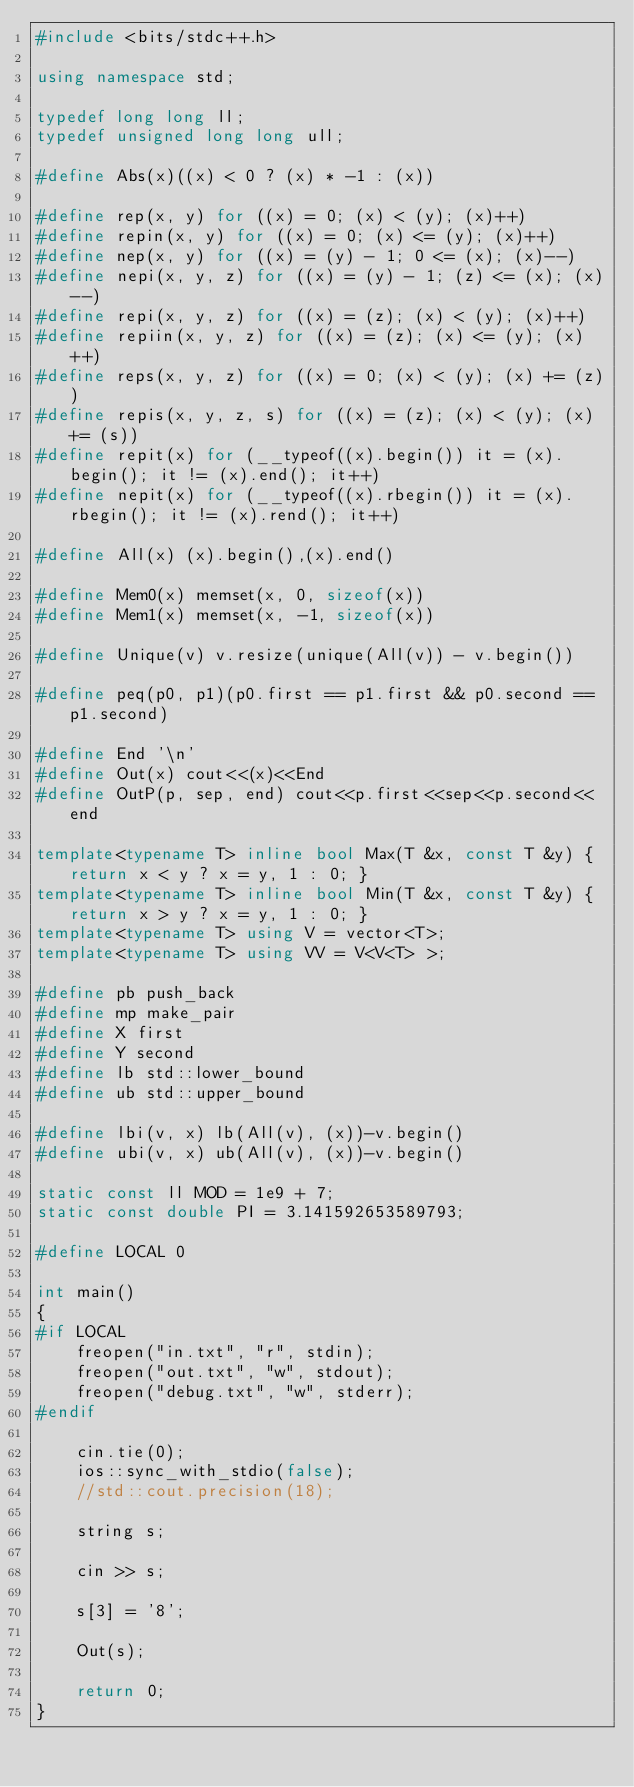Convert code to text. <code><loc_0><loc_0><loc_500><loc_500><_C++_>#include <bits/stdc++.h>

using namespace std;

typedef long long ll;
typedef unsigned long long ull;

#define Abs(x)((x) < 0 ? (x) * -1 : (x))

#define rep(x, y) for ((x) = 0; (x) < (y); (x)++)
#define repin(x, y) for ((x) = 0; (x) <= (y); (x)++)
#define nep(x, y) for ((x) = (y) - 1; 0 <= (x); (x)--)
#define nepi(x, y, z) for ((x) = (y) - 1; (z) <= (x); (x)--)
#define repi(x, y, z) for ((x) = (z); (x) < (y); (x)++)
#define repiin(x, y, z) for ((x) = (z); (x) <= (y); (x)++)
#define reps(x, y, z) for ((x) = 0; (x) < (y); (x) += (z))
#define repis(x, y, z, s) for ((x) = (z); (x) < (y); (x) += (s))
#define repit(x) for (__typeof((x).begin()) it = (x).begin(); it != (x).end(); it++)
#define nepit(x) for (__typeof((x).rbegin()) it = (x).rbegin(); it != (x).rend(); it++)

#define All(x) (x).begin(),(x).end()

#define Mem0(x) memset(x, 0, sizeof(x))
#define Mem1(x) memset(x, -1, sizeof(x))

#define Unique(v) v.resize(unique(All(v)) - v.begin())

#define peq(p0, p1)(p0.first == p1.first && p0.second == p1.second)

#define End '\n'
#define Out(x) cout<<(x)<<End
#define OutP(p, sep, end) cout<<p.first<<sep<<p.second<<end

template<typename T> inline bool Max(T &x, const T &y) { return x < y ? x = y, 1 : 0; }
template<typename T> inline bool Min(T &x, const T &y) { return x > y ? x = y, 1 : 0; }
template<typename T> using V = vector<T>;
template<typename T> using VV = V<V<T> >;

#define pb push_back
#define mp make_pair
#define X first
#define Y second
#define lb std::lower_bound
#define ub std::upper_bound

#define lbi(v, x) lb(All(v), (x))-v.begin()
#define ubi(v, x) ub(All(v), (x))-v.begin()

static const ll MOD = 1e9 + 7;
static const double PI = 3.141592653589793;

#define LOCAL 0

int main()
{
#if LOCAL
    freopen("in.txt", "r", stdin);
    freopen("out.txt", "w", stdout);
    freopen("debug.txt", "w", stderr);
#endif

    cin.tie(0);
    ios::sync_with_stdio(false);
	//std::cout.precision(18);

    string s;

	cin >> s;

	s[3] = '8';

	Out(s);
	
	return 0;
}
</code> 